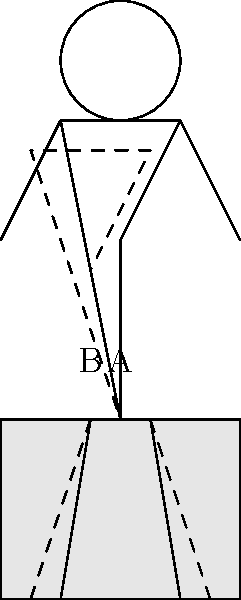Which sitting posture, A or B, is more likely to reduce pain for someone with an anal fissure? To determine the optimal sitting posture for someone with an anal fissure, we need to consider the following factors:

1. Pressure distribution: An anal fissure is a small tear in the lining of the anus, which can be painful when pressure is applied to the affected area.

2. Muscle tension: Sitting in a tense position can increase pressure on the anal area and exacerbate pain.

3. Blood flow: Proper posture can improve blood circulation to the affected area, promoting healing.

Analyzing the diagram:

Posture A (solid lines):
- The spine is straight and aligned vertically.
- The pelvis is in a neutral position.
- Weight is distributed evenly across the buttocks.
- Legs are relaxed and slightly apart.

Posture B (dashed lines):
- The spine is curved, creating a slouched position.
- The pelvis is tilted backward.
- More pressure is concentrated on the tailbone and anal area.
- Legs are closer together, potentially increasing muscle tension.

Posture A is more beneficial for someone with an anal fissure because:

1. It reduces direct pressure on the anal area by distributing weight more evenly.
2. The neutral pelvic position minimizes tension in the anal muscles.
3. The aligned spine and relaxed leg position promote better blood circulation.
4. It allows for better breathing and overall relaxation, which can help reduce pain.

In contrast, Posture B increases pressure on the anal area and may cause more discomfort and potentially slow down the healing process.
Answer: A 